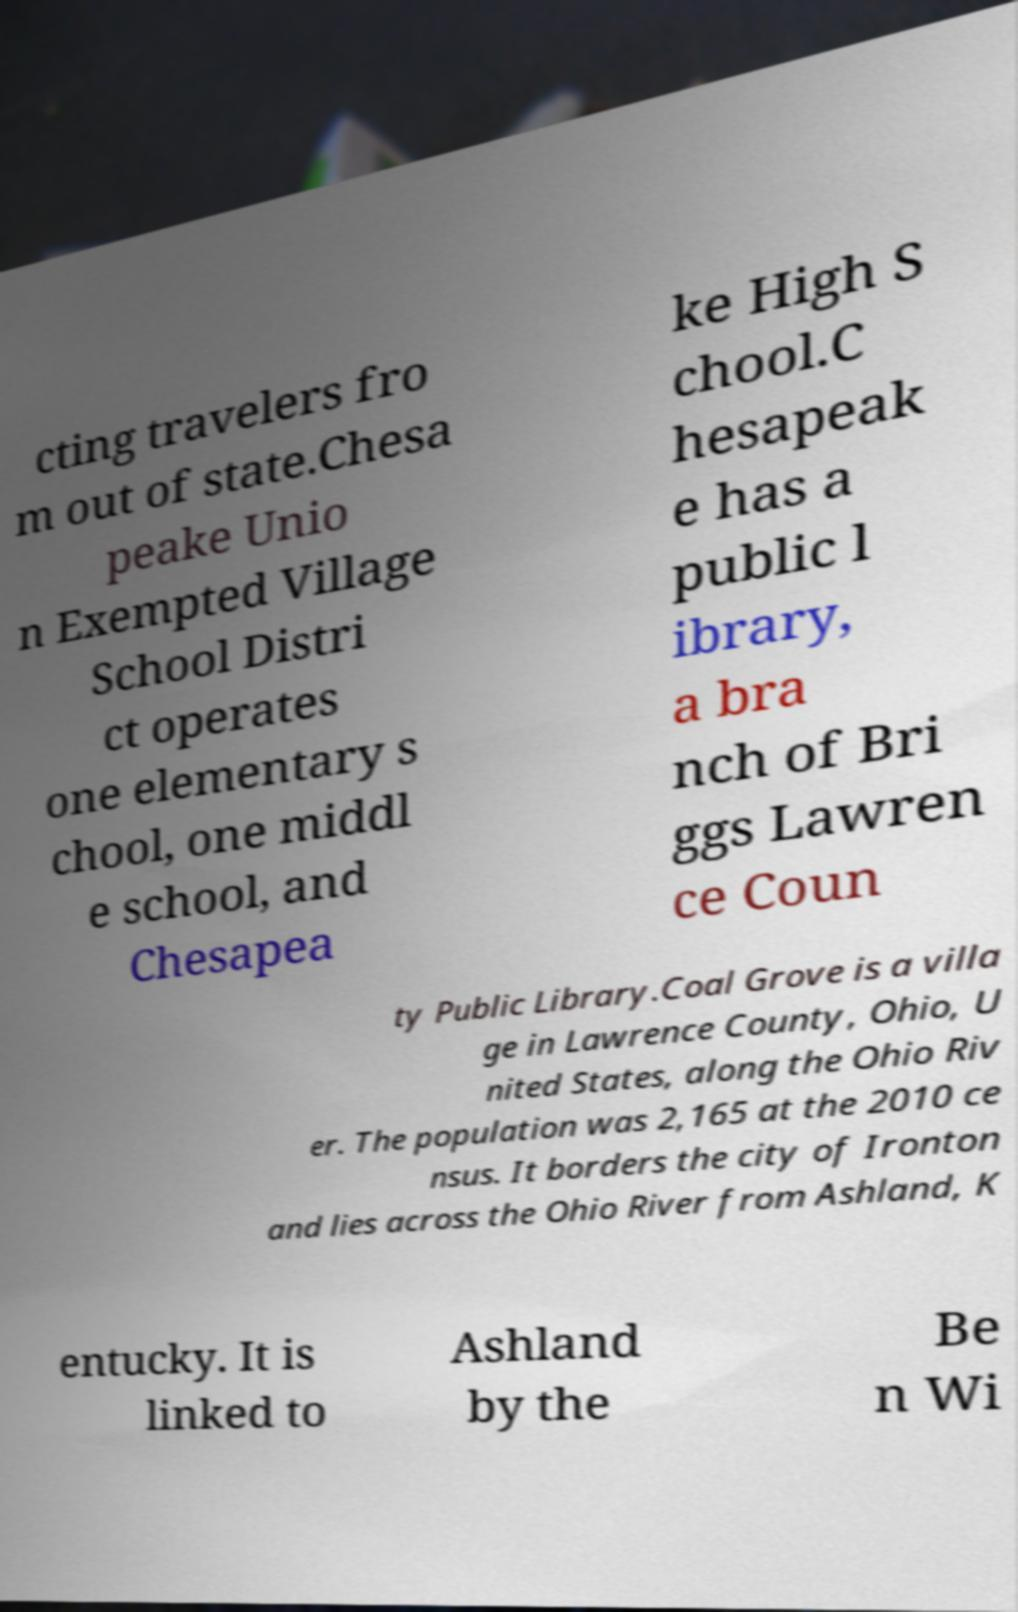Please read and relay the text visible in this image. What does it say? cting travelers fro m out of state.Chesa peake Unio n Exempted Village School Distri ct operates one elementary s chool, one middl e school, and Chesapea ke High S chool.C hesapeak e has a public l ibrary, a bra nch of Bri ggs Lawren ce Coun ty Public Library.Coal Grove is a villa ge in Lawrence County, Ohio, U nited States, along the Ohio Riv er. The population was 2,165 at the 2010 ce nsus. It borders the city of Ironton and lies across the Ohio River from Ashland, K entucky. It is linked to Ashland by the Be n Wi 